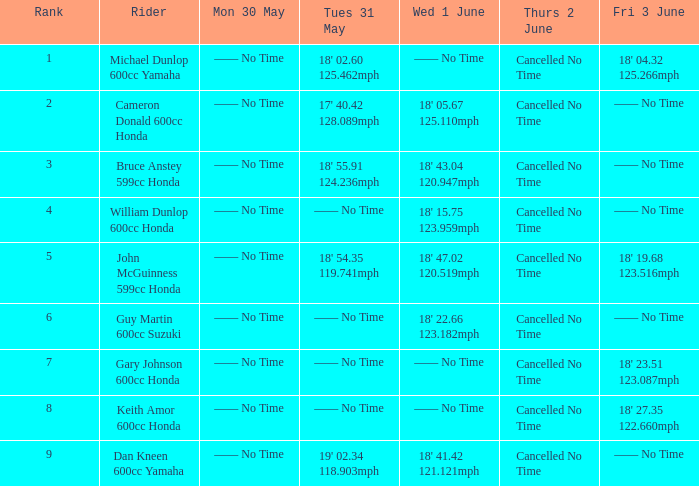What is the number of riders that had a Tues 31 May time of 18' 55.91 124.236mph? 1.0. 